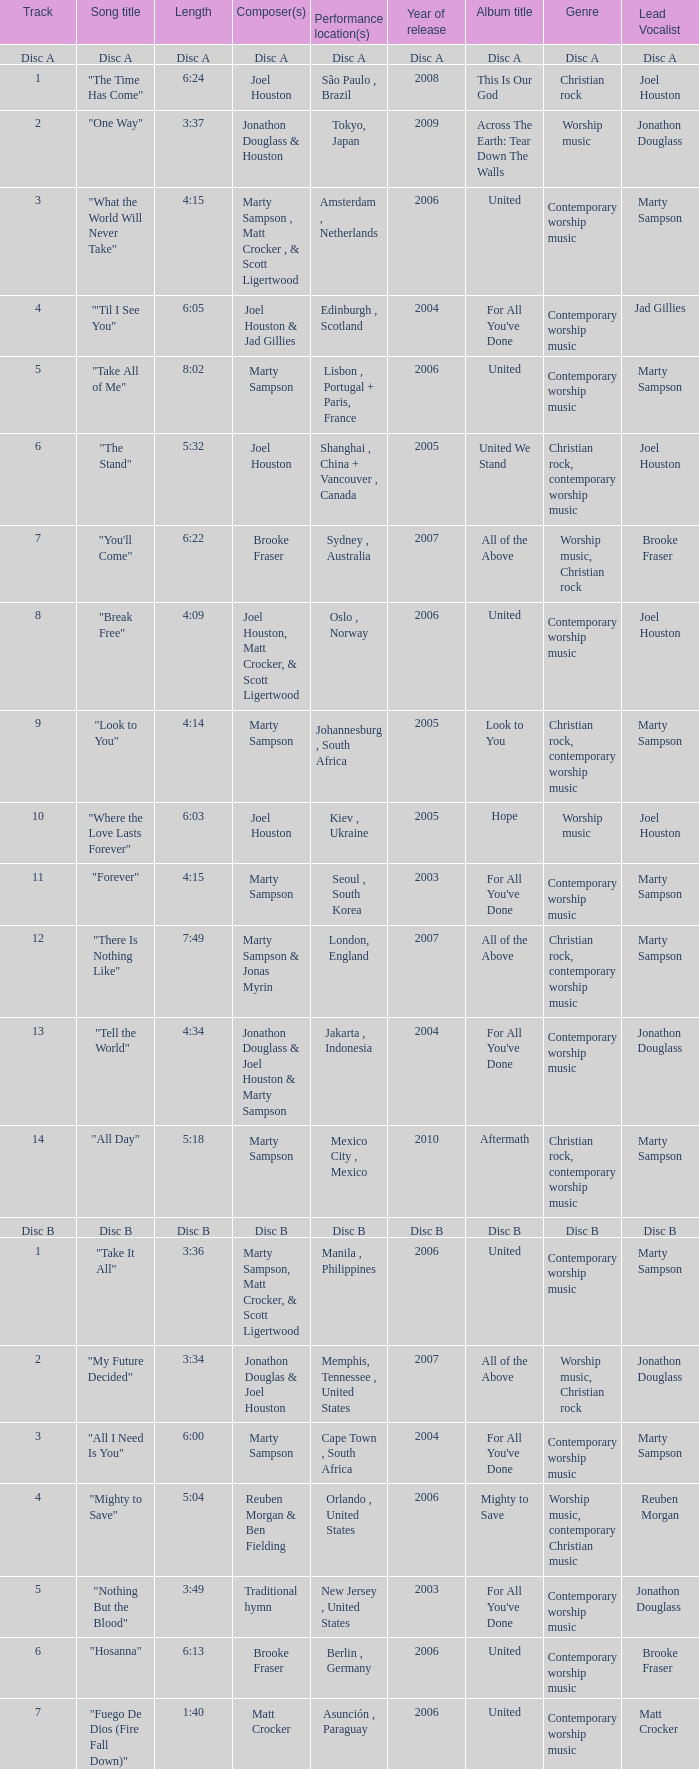What is the lengtho f track 16? 5:55. Help me parse the entirety of this table. {'header': ['Track', 'Song title', 'Length', 'Composer(s)', 'Performance location(s)', 'Year of release', 'Album title', 'Genre', 'Lead Vocalist'], 'rows': [['Disc A', 'Disc A', 'Disc A', 'Disc A', 'Disc A', 'Disc A', 'Disc A', 'Disc A', 'Disc A'], ['1', '"The Time Has Come"', '6:24', 'Joel Houston', 'São Paulo , Brazil', '2008', 'This Is Our God', 'Christian rock', 'Joel Houston'], ['2', '"One Way"', '3:37', 'Jonathon Douglass & Houston', 'Tokyo, Japan', '2009', 'Across The Earth: Tear Down The Walls', 'Worship music', 'Jonathon Douglass'], ['3', '"What the World Will Never Take"', '4:15', 'Marty Sampson , Matt Crocker , & Scott Ligertwood', 'Amsterdam , Netherlands', '2006', 'United', 'Contemporary worship music', 'Marty Sampson'], ['4', '"\'Til I See You"', '6:05', 'Joel Houston & Jad Gillies', 'Edinburgh , Scotland', '2004', "For All You've Done", 'Contemporary worship music', 'Jad Gillies'], ['5', '"Take All of Me"', '8:02', 'Marty Sampson', 'Lisbon , Portugal + Paris, France', '2006', 'United', 'Contemporary worship music', 'Marty Sampson'], ['6', '"The Stand"', '5:32', 'Joel Houston', 'Shanghai , China + Vancouver , Canada', '2005', 'United We Stand', 'Christian rock, contemporary worship music', 'Joel Houston'], ['7', '"You\'ll Come"', '6:22', 'Brooke Fraser', 'Sydney , Australia', '2007', 'All of the Above', 'Worship music, Christian rock', 'Brooke Fraser'], ['8', '"Break Free"', '4:09', 'Joel Houston, Matt Crocker, & Scott Ligertwood', 'Oslo , Norway', '2006', 'United', 'Contemporary worship music', 'Joel Houston'], ['9', '"Look to You"', '4:14', 'Marty Sampson', 'Johannesburg , South Africa', '2005', 'Look to You', 'Christian rock, contemporary worship music', 'Marty Sampson'], ['10', '"Where the Love Lasts Forever"', '6:03', 'Joel Houston', 'Kiev , Ukraine', '2005', 'Hope', 'Worship music', 'Joel Houston'], ['11', '"Forever"', '4:15', 'Marty Sampson', 'Seoul , South Korea', '2003', "For All You've Done", 'Contemporary worship music', 'Marty Sampson'], ['12', '"There Is Nothing Like"', '7:49', 'Marty Sampson & Jonas Myrin', 'London, England', '2007', 'All of the Above', 'Christian rock, contemporary worship music', 'Marty Sampson'], ['13', '"Tell the World"', '4:34', 'Jonathon Douglass & Joel Houston & Marty Sampson', 'Jakarta , Indonesia', '2004', "For All You've Done", 'Contemporary worship music', 'Jonathon Douglass'], ['14', '"All Day"', '5:18', 'Marty Sampson', 'Mexico City , Mexico', '2010', 'Aftermath', 'Christian rock, contemporary worship music', 'Marty Sampson'], ['Disc B', 'Disc B', 'Disc B', 'Disc B', 'Disc B', 'Disc B', 'Disc B', 'Disc B', 'Disc B'], ['1', '"Take It All"', '3:36', 'Marty Sampson, Matt Crocker, & Scott Ligertwood', 'Manila , Philippines', '2006', 'United', 'Contemporary worship music', 'Marty Sampson'], ['2', '"My Future Decided"', '3:34', 'Jonathon Douglas & Joel Houston', 'Memphis, Tennessee , United States', '2007', 'All of the Above', 'Worship music, Christian rock', 'Jonathon Douglass'], ['3', '"All I Need Is You"', '6:00', 'Marty Sampson', 'Cape Town , South Africa', '2004', "For All You've Done", 'Contemporary worship music', 'Marty Sampson'], ['4', '"Mighty to Save"', '5:04', 'Reuben Morgan & Ben Fielding', 'Orlando , United States', '2006', 'Mighty to Save', 'Worship music, contemporary Christian music', 'Reuben Morgan'], ['5', '"Nothing But the Blood"', '3:49', 'Traditional hymn', 'New Jersey , United States', '2003', "For All You've Done", 'Contemporary worship music', 'Jonathon Douglass '], ['6', '"Hosanna"', '6:13', 'Brooke Fraser', 'Berlin , Germany', '2006', 'United', 'Contemporary worship music', 'Brooke Fraser'], ['7', '"Fuego De Dios (Fire Fall Down)"', '1:40', 'Matt Crocker', 'Asunción , Paraguay', '2006', 'United', 'Contemporary worship music', 'Matt Crocker '], ['8', '"Shout Unto God"', '4:14', 'Joel Houston & Marty Sampson', 'Buenos Aires , Argentina + Copenhagen , Denmark', '2005', 'Look to You', 'Christian rock, contemporary worship music', 'Joel Houston'], ['9', '"Salvation Is Here"', '4:03', 'Joel Houston', 'Budapest , Hungary', '2004', "For All You've Done", 'Christian rock, contemporary worship music', 'Joel Houston '], ['10', '"Love Enough"', '3:04', 'Braden Lang & Scott Ligertwood', 'Sydney, Australia', '2007', 'All of the Above', 'Worship music, Christian rock', 'Braden Lang'], ['11', '"More Than Life"', '6:29', 'Morgan', 'Orlando, United States', '2004', "For All You've Done", 'Christian rock, contemporary worship music', 'Morgan'], ['12', '"None But Jesus"', '7:58', 'Brooke Fraser', 'Toronto , Canada + Buenos Aires, Argentina', '2006', 'United', 'Contemporary worship music', 'Brooke Fraser'], ['13', '"From the Inside Out"', '5:59', 'Joel Houston', 'Rio de Janeiro , Brazil', '2006', 'United', 'Christian rock, contemporary worship music', 'Joel Houston'], ['14', '"Came to My Rescue"', '3:43', 'Marty Sampson, Dylan Thomas, & Joel Davies', 'Kuala Lumpur , Malaysia', '2005', 'United We Stand', 'Christian rock, contemporary worship music', 'Marty Sampson'], ['15', '"Saviour King"', '7:03', 'Marty Sampson & Mia Fieldes', 'Västerås , Sweden', '2007', 'All of the Above', 'Christian rock, contemporary worship music', 'Marty Sampson'], ['16', '"Solution"', '5:55', 'Joel Houston & Matt Crocker', 'Los Angeles , United States', '2006', 'United', 'Christian rock, contemporary worship music', 'Joel Houston']]} 